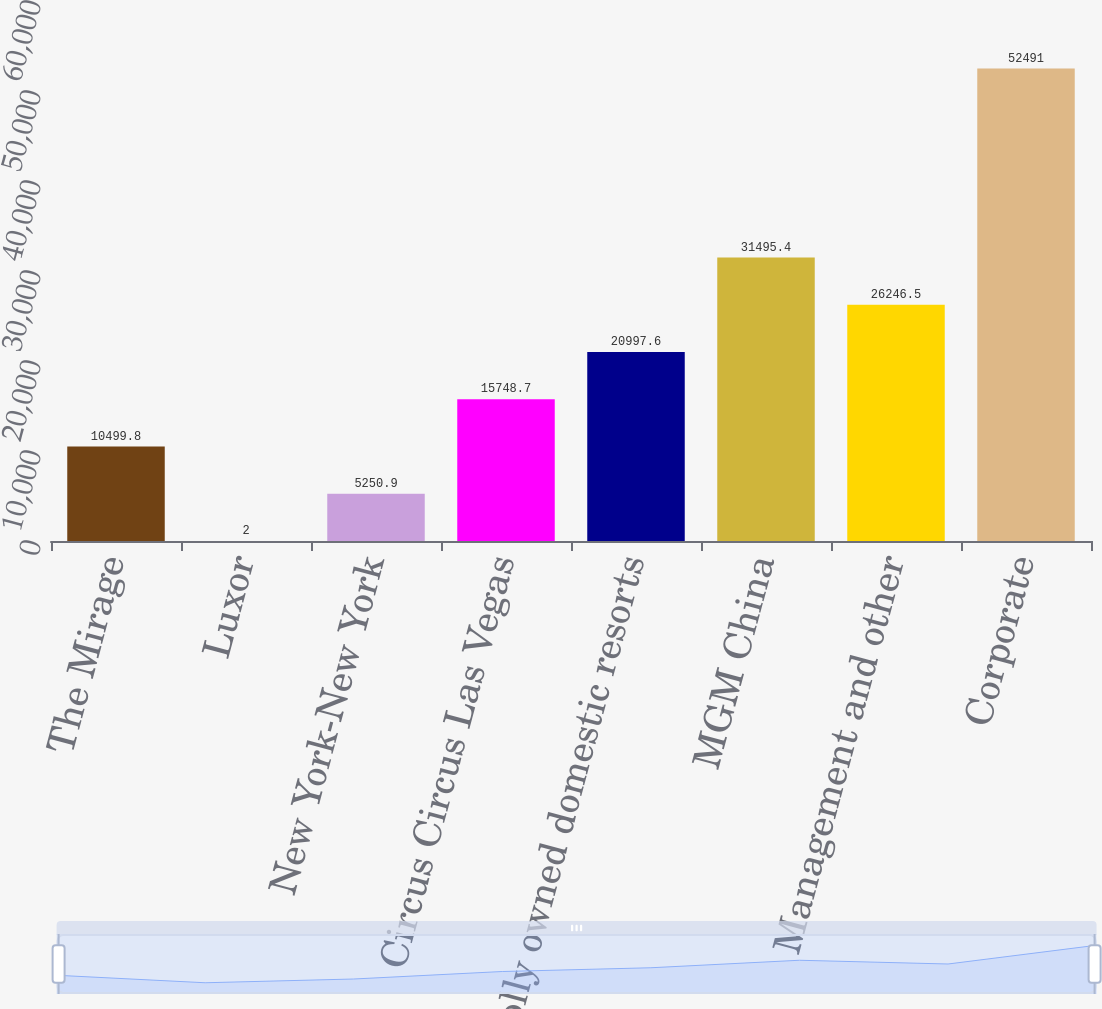Convert chart to OTSL. <chart><loc_0><loc_0><loc_500><loc_500><bar_chart><fcel>The Mirage<fcel>Luxor<fcel>New York-New York<fcel>Circus Circus Las Vegas<fcel>Wholly owned domestic resorts<fcel>MGM China<fcel>Management and other<fcel>Corporate<nl><fcel>10499.8<fcel>2<fcel>5250.9<fcel>15748.7<fcel>20997.6<fcel>31495.4<fcel>26246.5<fcel>52491<nl></chart> 